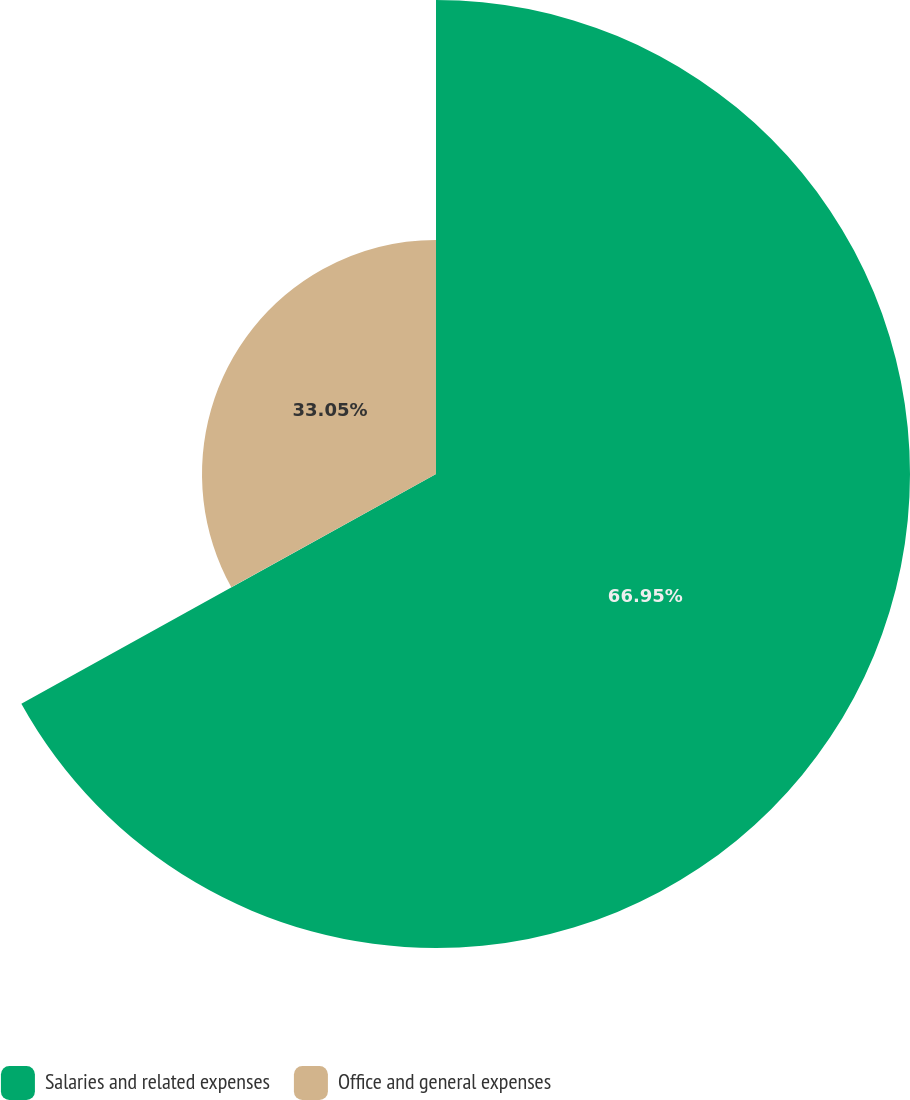<chart> <loc_0><loc_0><loc_500><loc_500><pie_chart><fcel>Salaries and related expenses<fcel>Office and general expenses<nl><fcel>66.95%<fcel>33.05%<nl></chart> 